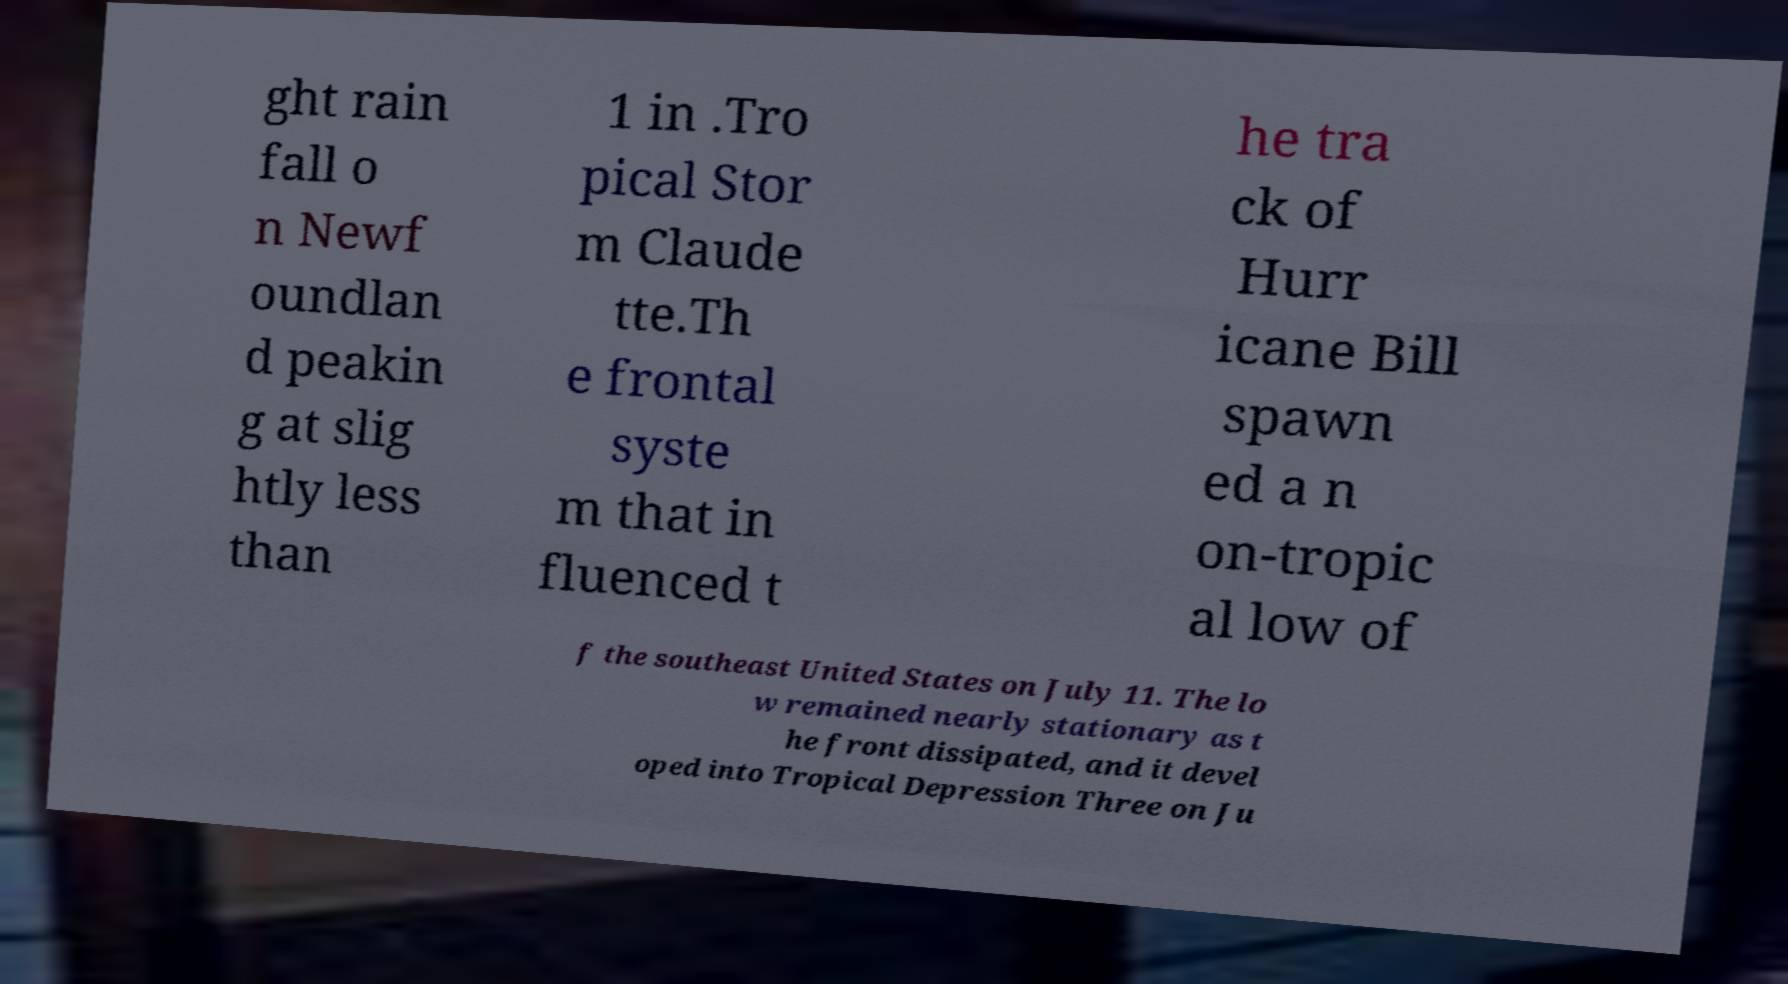There's text embedded in this image that I need extracted. Can you transcribe it verbatim? ght rain fall o n Newf oundlan d peakin g at slig htly less than 1 in .Tro pical Stor m Claude tte.Th e frontal syste m that in fluenced t he tra ck of Hurr icane Bill spawn ed a n on-tropic al low of f the southeast United States on July 11. The lo w remained nearly stationary as t he front dissipated, and it devel oped into Tropical Depression Three on Ju 